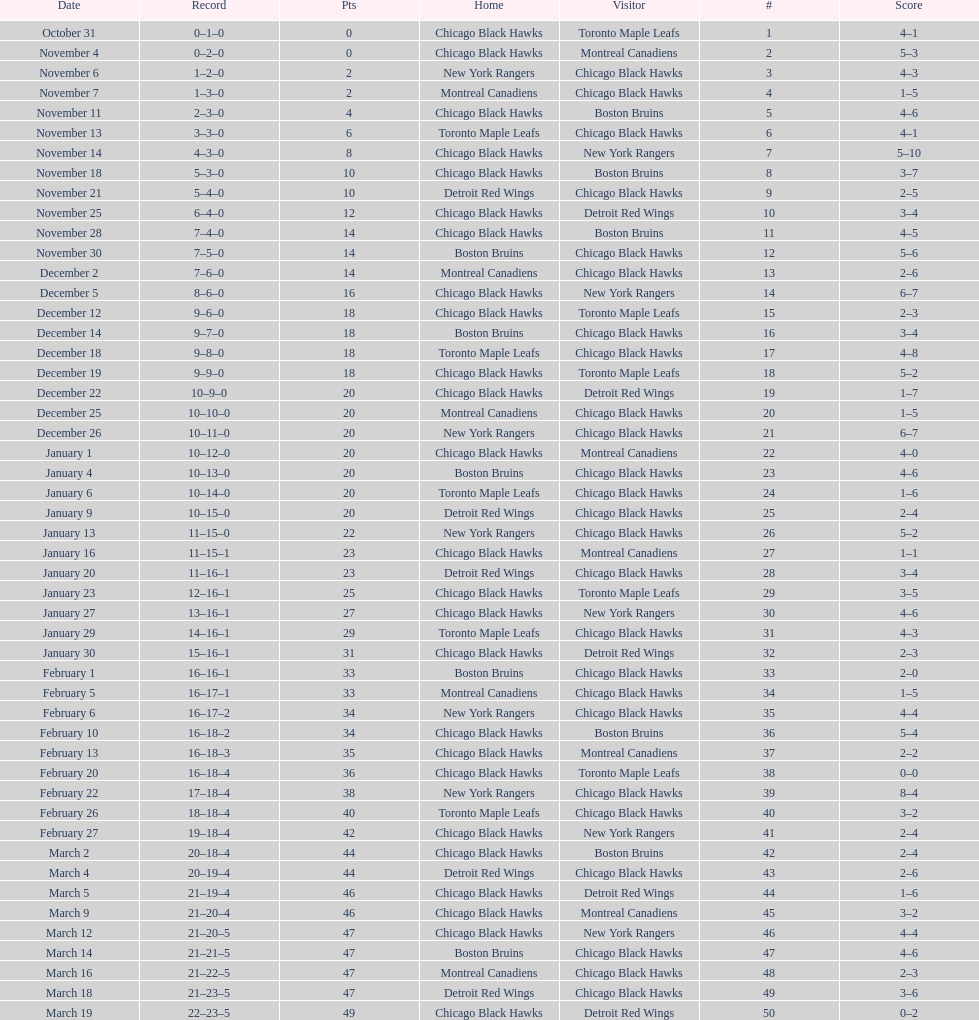How many total games did they win? 22. 